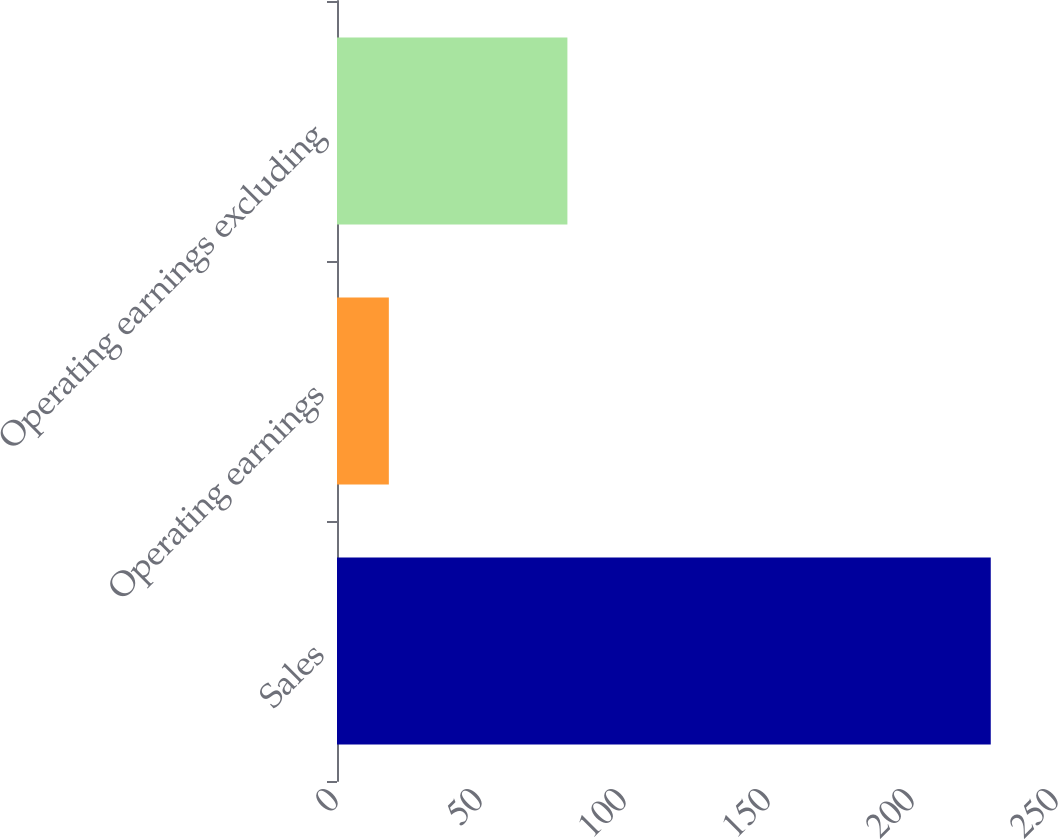<chart> <loc_0><loc_0><loc_500><loc_500><bar_chart><fcel>Sales<fcel>Operating earnings<fcel>Operating earnings excluding<nl><fcel>227<fcel>18<fcel>80<nl></chart> 